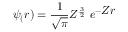Convert formula to latex. <formula><loc_0><loc_0><loc_500><loc_500>\psi _ { ( } r ) = { \frac { 1 } { \sqrt { \pi } } } Z ^ { \frac { 3 } { 2 } } \ e ^ { - { Z r } }</formula> 